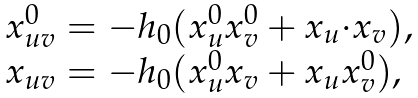<formula> <loc_0><loc_0><loc_500><loc_500>\begin{array} { l } x ^ { 0 } _ { u v } = - h _ { 0 } ( x ^ { 0 } _ { u } x ^ { 0 } _ { v } + { x } _ { u } { \cdot } { x } _ { v } ) , \\ { x } _ { u v } = - h _ { 0 } ( x ^ { 0 } _ { u } { x } _ { v } + { x } _ { u } x ^ { 0 } _ { v } ) , \end{array}</formula> 